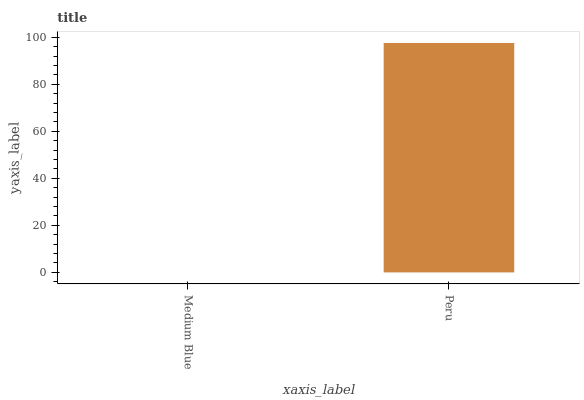Is Medium Blue the minimum?
Answer yes or no. Yes. Is Peru the maximum?
Answer yes or no. Yes. Is Peru the minimum?
Answer yes or no. No. Is Peru greater than Medium Blue?
Answer yes or no. Yes. Is Medium Blue less than Peru?
Answer yes or no. Yes. Is Medium Blue greater than Peru?
Answer yes or no. No. Is Peru less than Medium Blue?
Answer yes or no. No. Is Peru the high median?
Answer yes or no. Yes. Is Medium Blue the low median?
Answer yes or no. Yes. Is Medium Blue the high median?
Answer yes or no. No. Is Peru the low median?
Answer yes or no. No. 